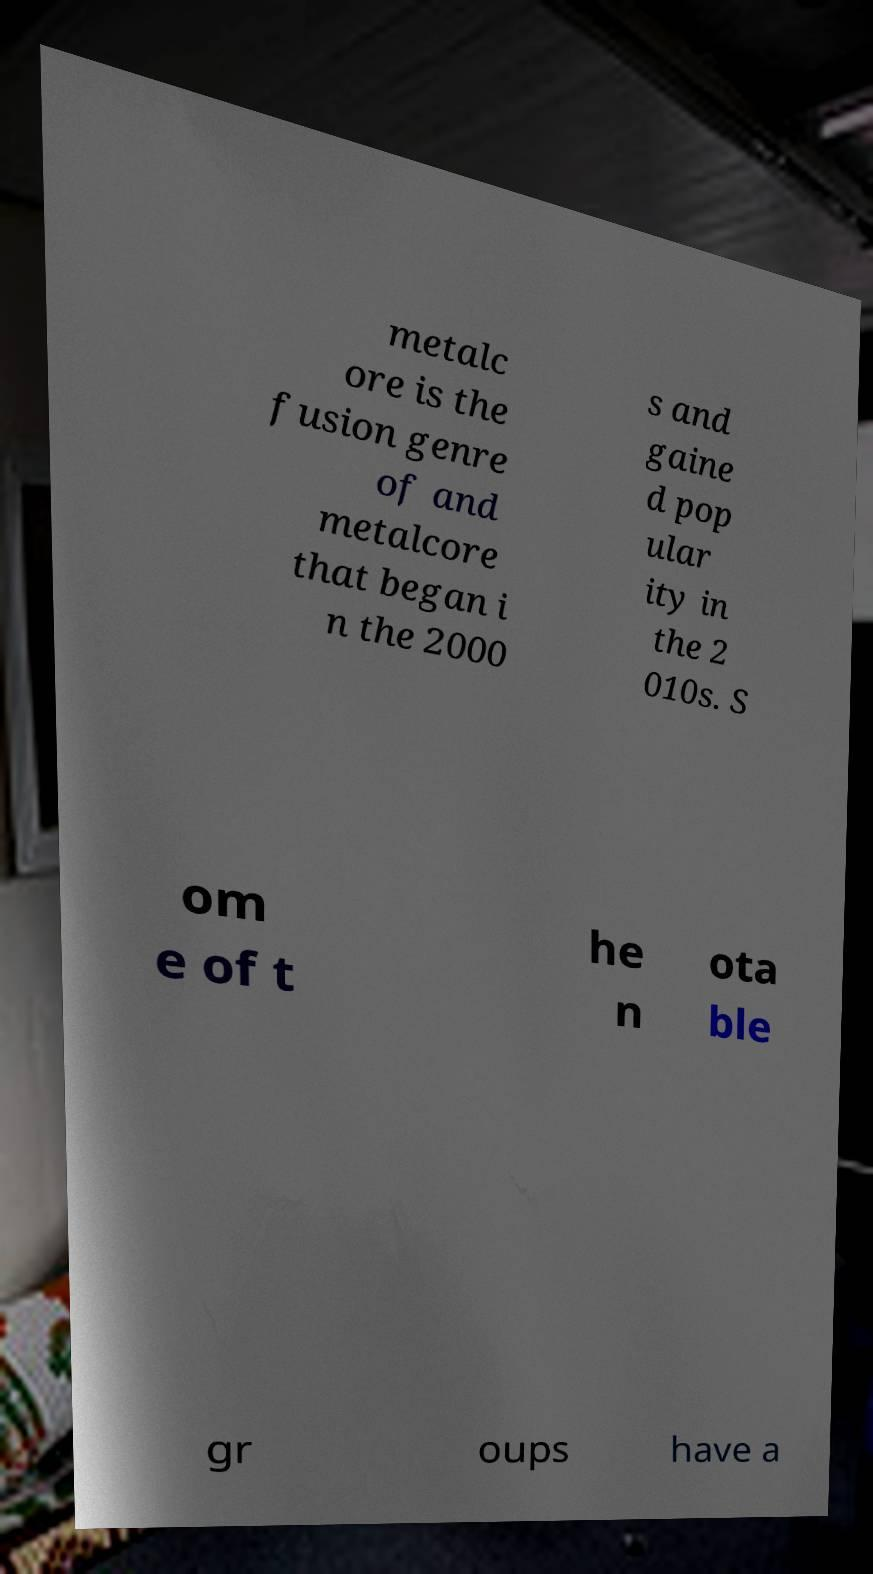Could you extract and type out the text from this image? metalc ore is the fusion genre of and metalcore that began i n the 2000 s and gaine d pop ular ity in the 2 010s. S om e of t he n ota ble gr oups have a 